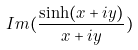Convert formula to latex. <formula><loc_0><loc_0><loc_500><loc_500>I m ( \frac { \sinh ( x + i y ) } { x + i y } )</formula> 